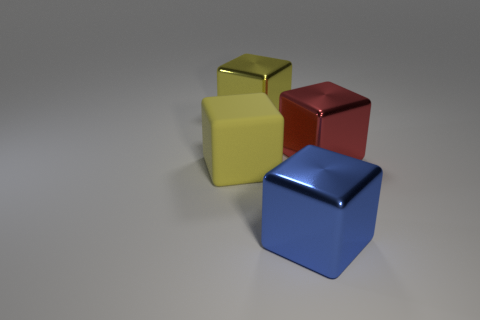Subtract all matte cubes. How many cubes are left? 3 Subtract 2 cubes. How many cubes are left? 2 Add 3 blocks. How many blocks are left? 7 Add 2 big yellow things. How many big yellow things exist? 4 Add 2 big red cylinders. How many objects exist? 6 Subtract all blue blocks. How many blocks are left? 3 Subtract 0 yellow cylinders. How many objects are left? 4 Subtract all blue cubes. Subtract all red cylinders. How many cubes are left? 3 Subtract all cyan cylinders. How many purple blocks are left? 0 Subtract all red metallic cubes. Subtract all purple metal cubes. How many objects are left? 3 